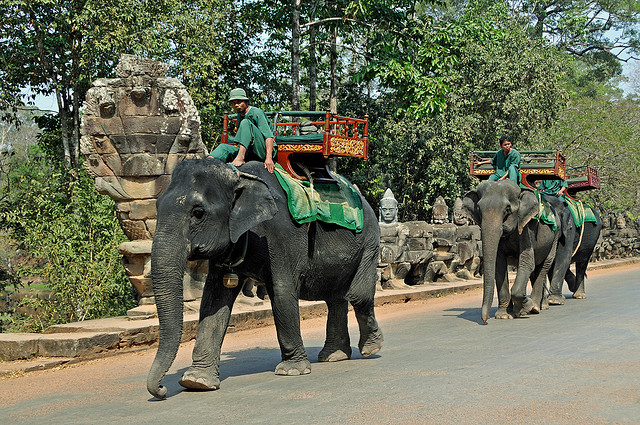What is the current situation regarding elephant conservation in Thailand? Thailand has made strides in elephant conservation but faces ongoing challenges. Due to habitat loss and other factors, the population of wild elephants is under threat. However, there are numerous sanctuaries and conservation programs dedicated to protecting these animals. These initiatives advocate ethical tourism, avoiding elephant rides and instead offering opportunities for visitors to observe and assist with the daily care of elephants in a respectful and sustainable manner. 